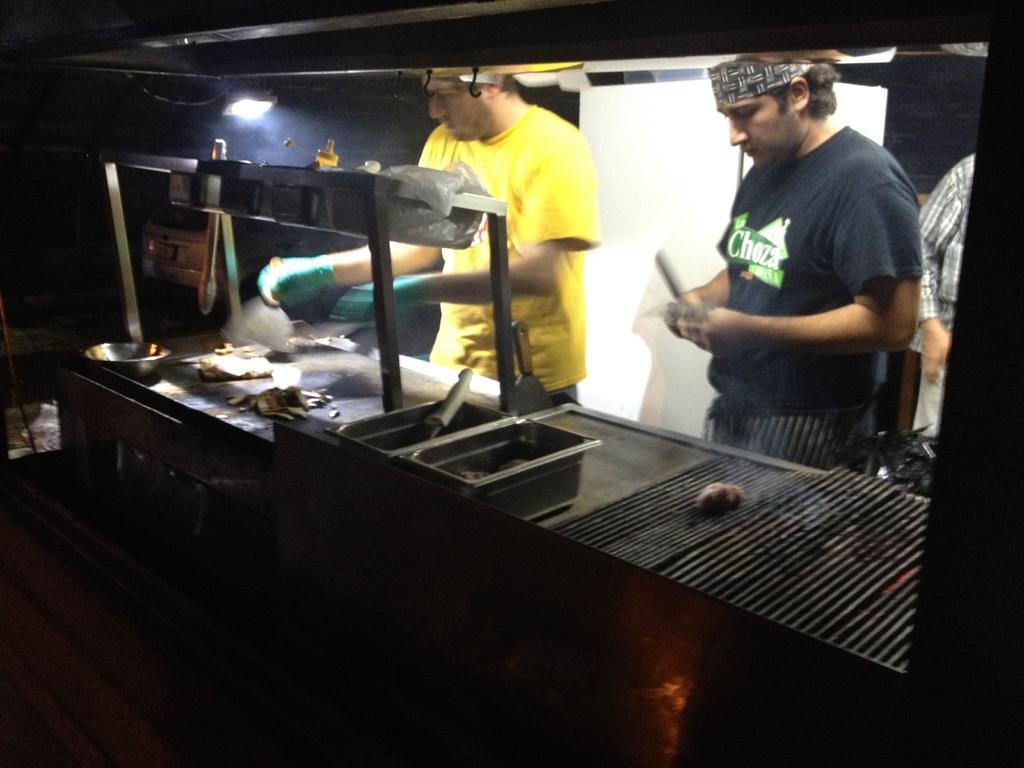Could you give a brief overview of what you see in this image? 2 people are standing. They are cooking. The person at the center is wearing a yellow t shirt and there is a light on the top. 